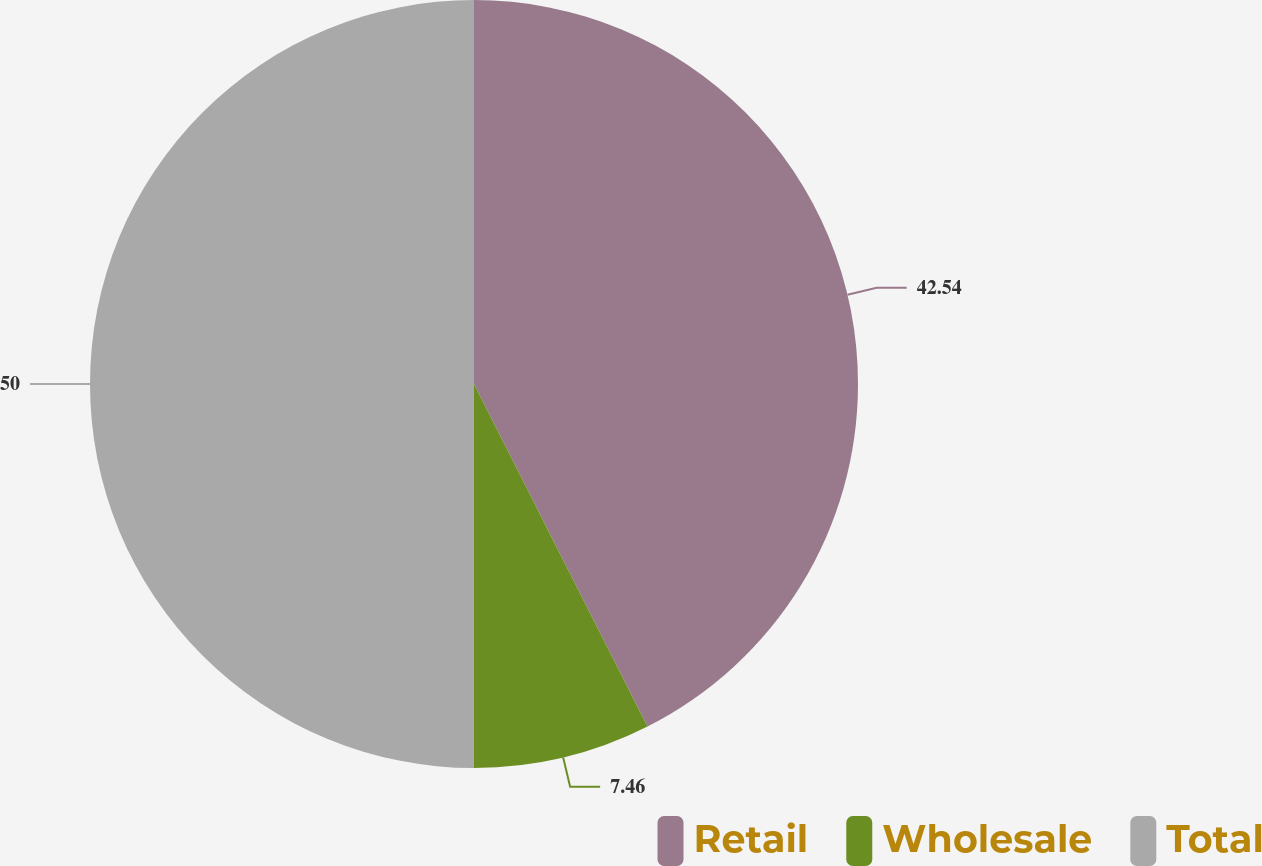Convert chart to OTSL. <chart><loc_0><loc_0><loc_500><loc_500><pie_chart><fcel>Retail<fcel>Wholesale<fcel>Total<nl><fcel>42.54%<fcel>7.46%<fcel>50.0%<nl></chart> 